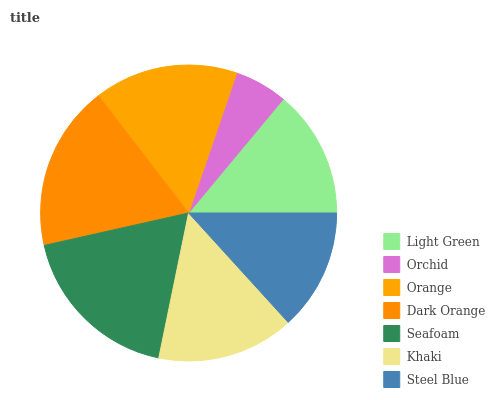Is Orchid the minimum?
Answer yes or no. Yes. Is Seafoam the maximum?
Answer yes or no. Yes. Is Orange the minimum?
Answer yes or no. No. Is Orange the maximum?
Answer yes or no. No. Is Orange greater than Orchid?
Answer yes or no. Yes. Is Orchid less than Orange?
Answer yes or no. Yes. Is Orchid greater than Orange?
Answer yes or no. No. Is Orange less than Orchid?
Answer yes or no. No. Is Khaki the high median?
Answer yes or no. Yes. Is Khaki the low median?
Answer yes or no. Yes. Is Seafoam the high median?
Answer yes or no. No. Is Orange the low median?
Answer yes or no. No. 